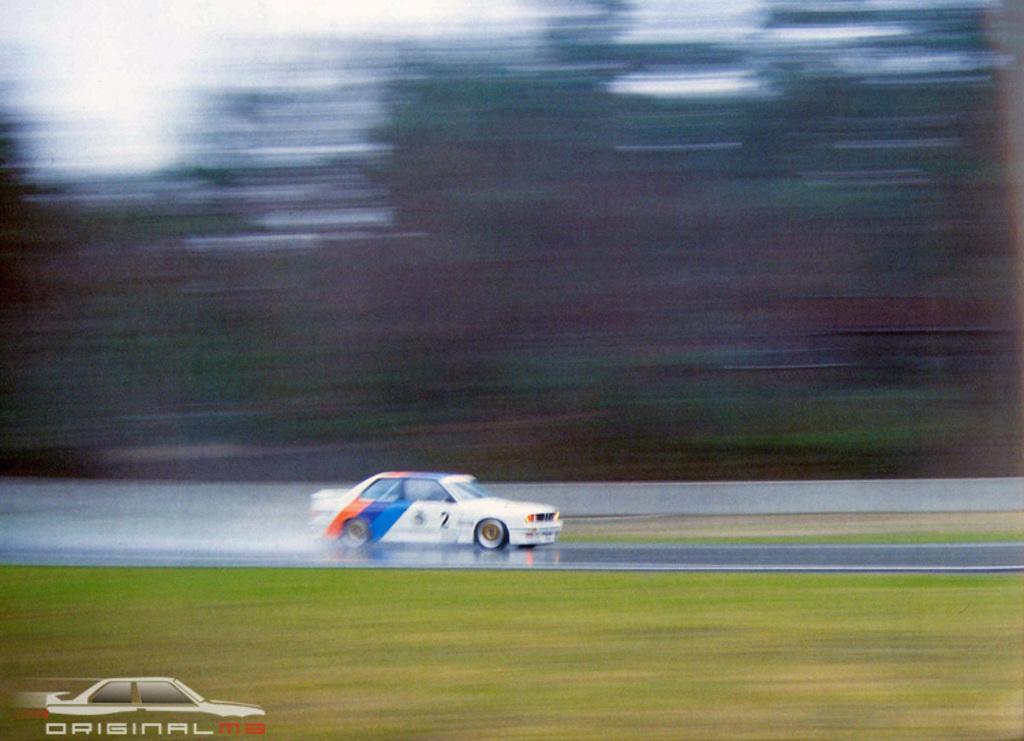Please provide a concise description of this image. This image consists of a car in white color. At the bottom, there is a road and green grass. In the background there are trees and it is blurred. 